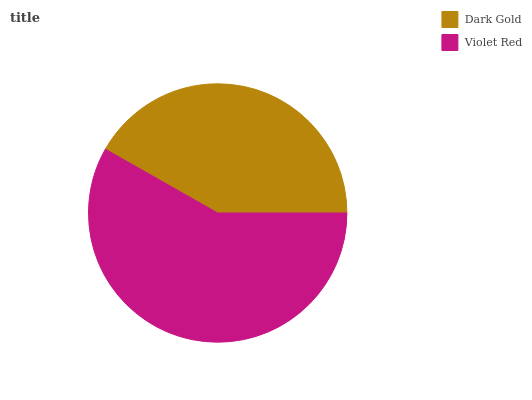Is Dark Gold the minimum?
Answer yes or no. Yes. Is Violet Red the maximum?
Answer yes or no. Yes. Is Violet Red the minimum?
Answer yes or no. No. Is Violet Red greater than Dark Gold?
Answer yes or no. Yes. Is Dark Gold less than Violet Red?
Answer yes or no. Yes. Is Dark Gold greater than Violet Red?
Answer yes or no. No. Is Violet Red less than Dark Gold?
Answer yes or no. No. Is Violet Red the high median?
Answer yes or no. Yes. Is Dark Gold the low median?
Answer yes or no. Yes. Is Dark Gold the high median?
Answer yes or no. No. Is Violet Red the low median?
Answer yes or no. No. 